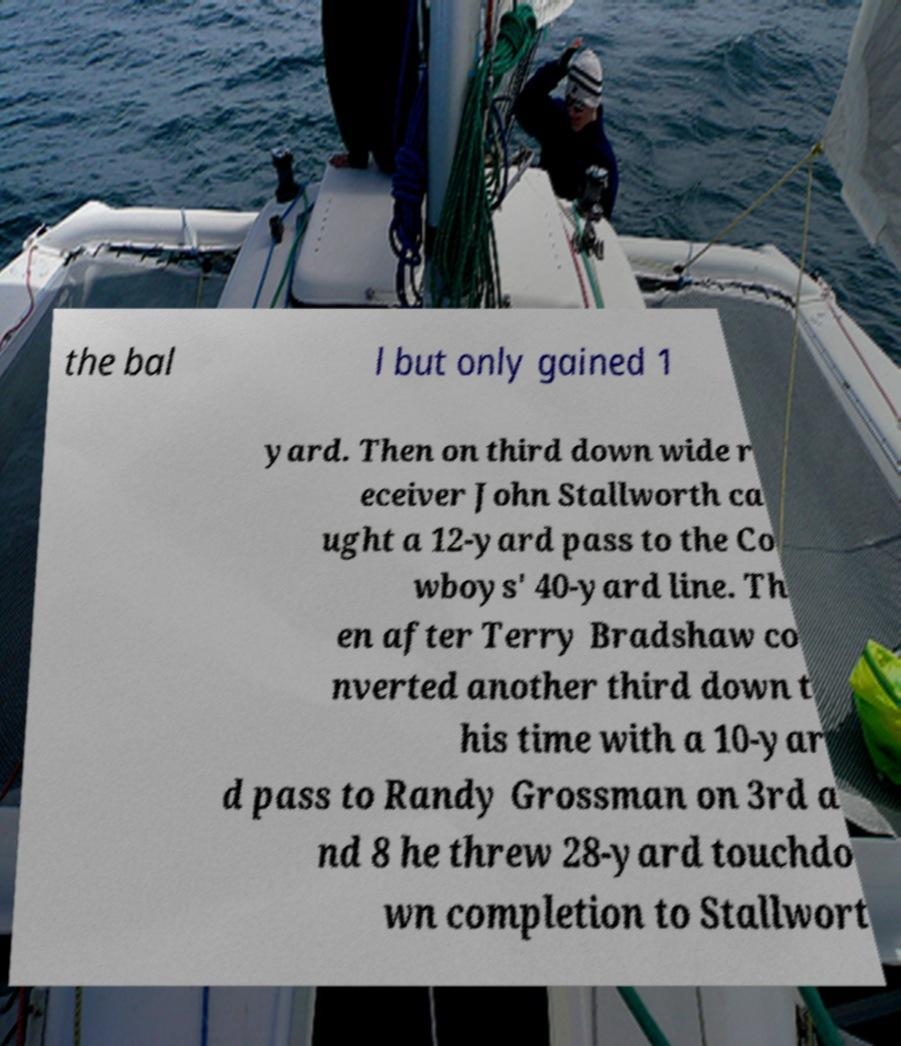Can you accurately transcribe the text from the provided image for me? the bal l but only gained 1 yard. Then on third down wide r eceiver John Stallworth ca ught a 12-yard pass to the Co wboys' 40-yard line. Th en after Terry Bradshaw co nverted another third down t his time with a 10-yar d pass to Randy Grossman on 3rd a nd 8 he threw 28-yard touchdo wn completion to Stallwort 